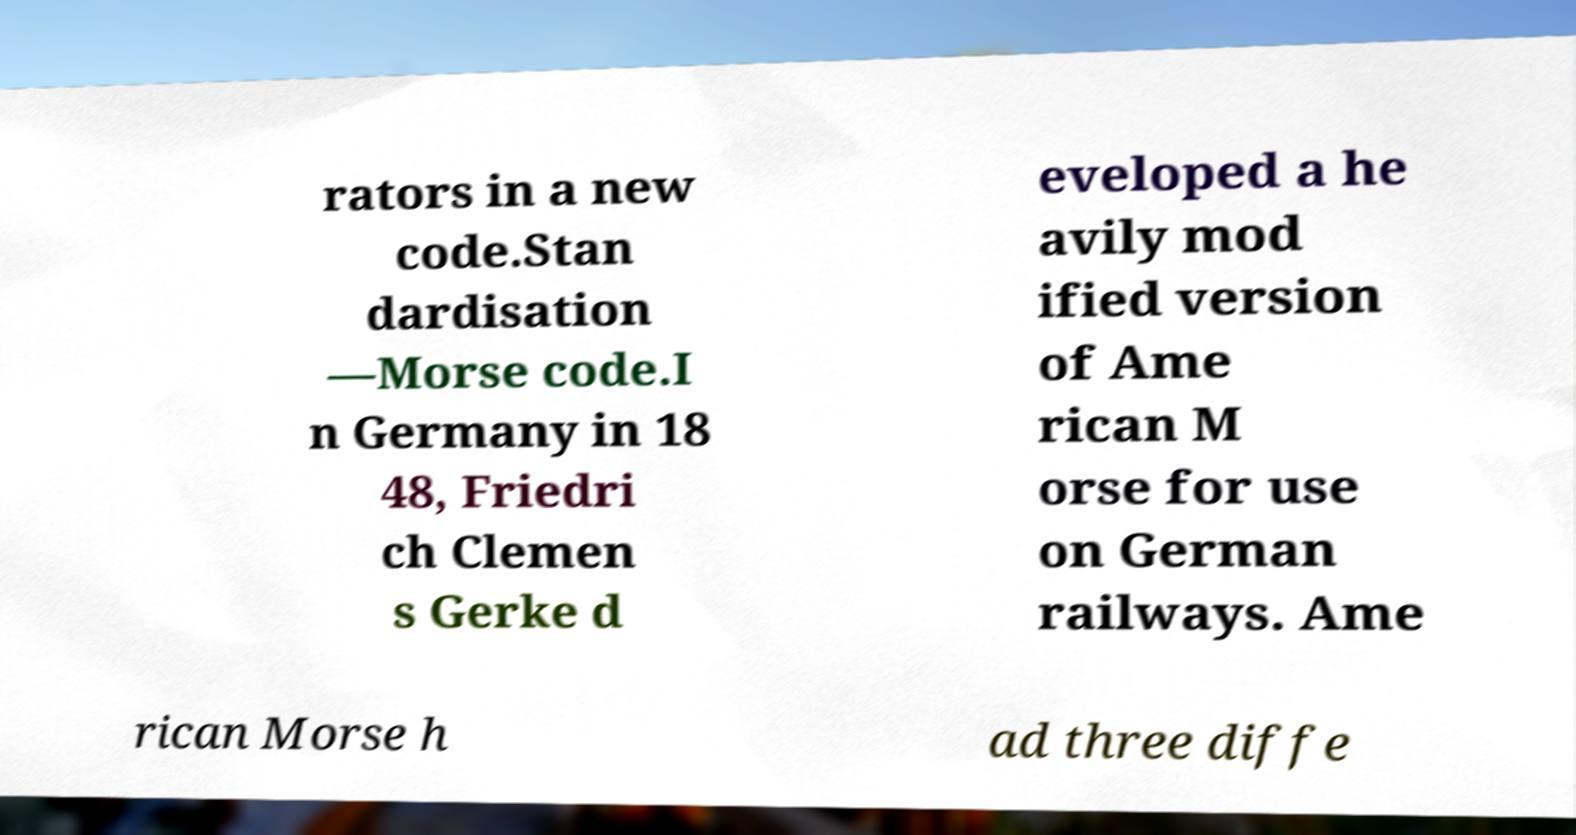There's text embedded in this image that I need extracted. Can you transcribe it verbatim? rators in a new code.Stan dardisation —Morse code.I n Germany in 18 48, Friedri ch Clemen s Gerke d eveloped a he avily mod ified version of Ame rican M orse for use on German railways. Ame rican Morse h ad three diffe 